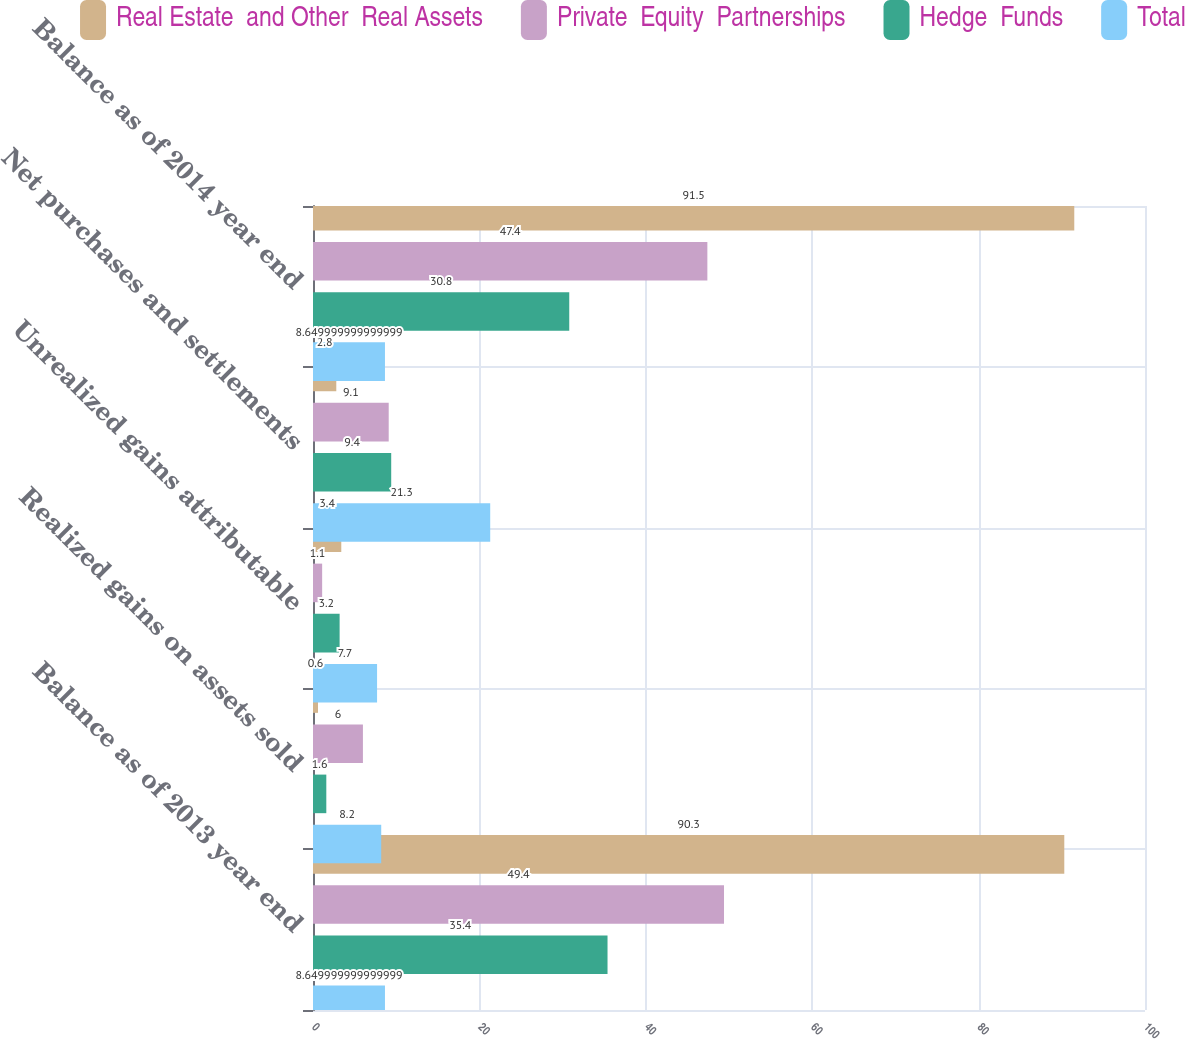Convert chart to OTSL. <chart><loc_0><loc_0><loc_500><loc_500><stacked_bar_chart><ecel><fcel>Balance as of 2013 year end<fcel>Realized gains on assets sold<fcel>Unrealized gains attributable<fcel>Net purchases and settlements<fcel>Balance as of 2014 year end<nl><fcel>Real Estate  and Other  Real Assets<fcel>90.3<fcel>0.6<fcel>3.4<fcel>2.8<fcel>91.5<nl><fcel>Private  Equity  Partnerships<fcel>49.4<fcel>6<fcel>1.1<fcel>9.1<fcel>47.4<nl><fcel>Hedge  Funds<fcel>35.4<fcel>1.6<fcel>3.2<fcel>9.4<fcel>30.8<nl><fcel>Total<fcel>8.65<fcel>8.2<fcel>7.7<fcel>21.3<fcel>8.65<nl></chart> 